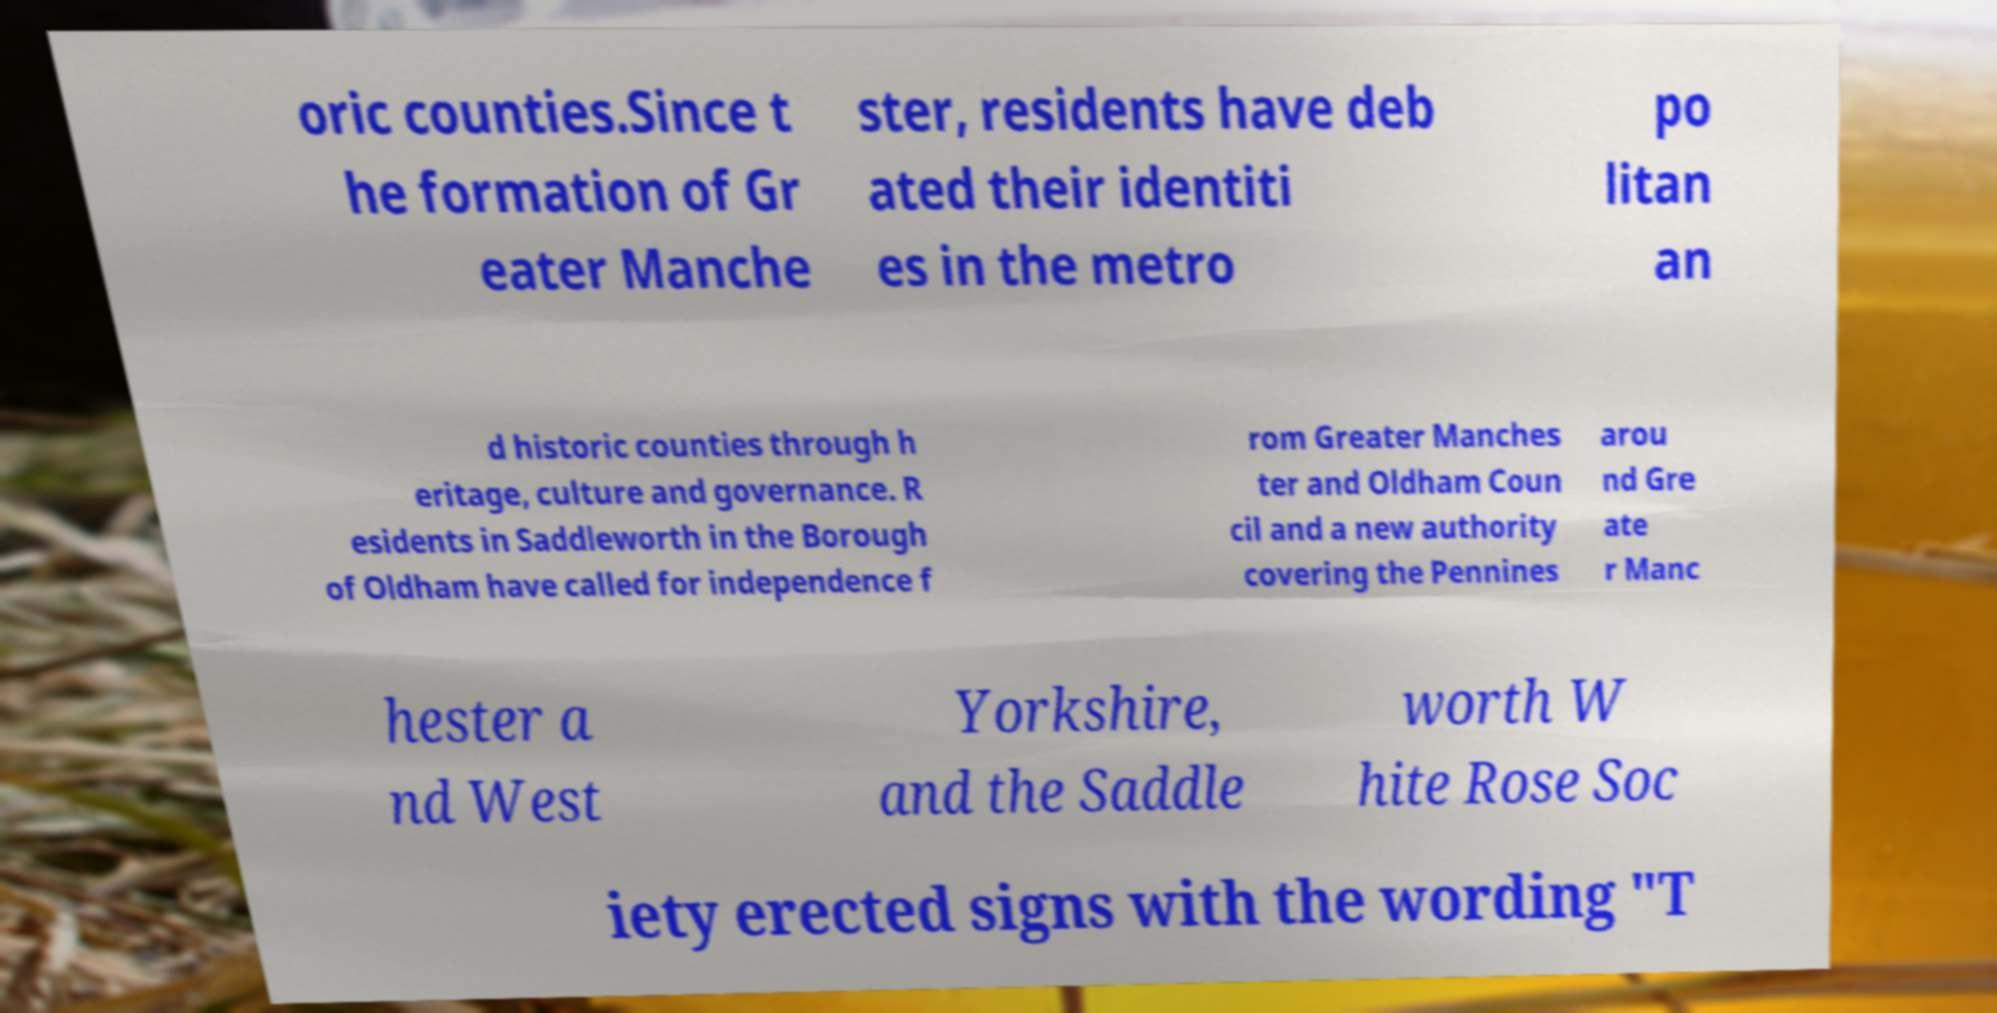Could you assist in decoding the text presented in this image and type it out clearly? oric counties.Since t he formation of Gr eater Manche ster, residents have deb ated their identiti es in the metro po litan an d historic counties through h eritage, culture and governance. R esidents in Saddleworth in the Borough of Oldham have called for independence f rom Greater Manches ter and Oldham Coun cil and a new authority covering the Pennines arou nd Gre ate r Manc hester a nd West Yorkshire, and the Saddle worth W hite Rose Soc iety erected signs with the wording "T 